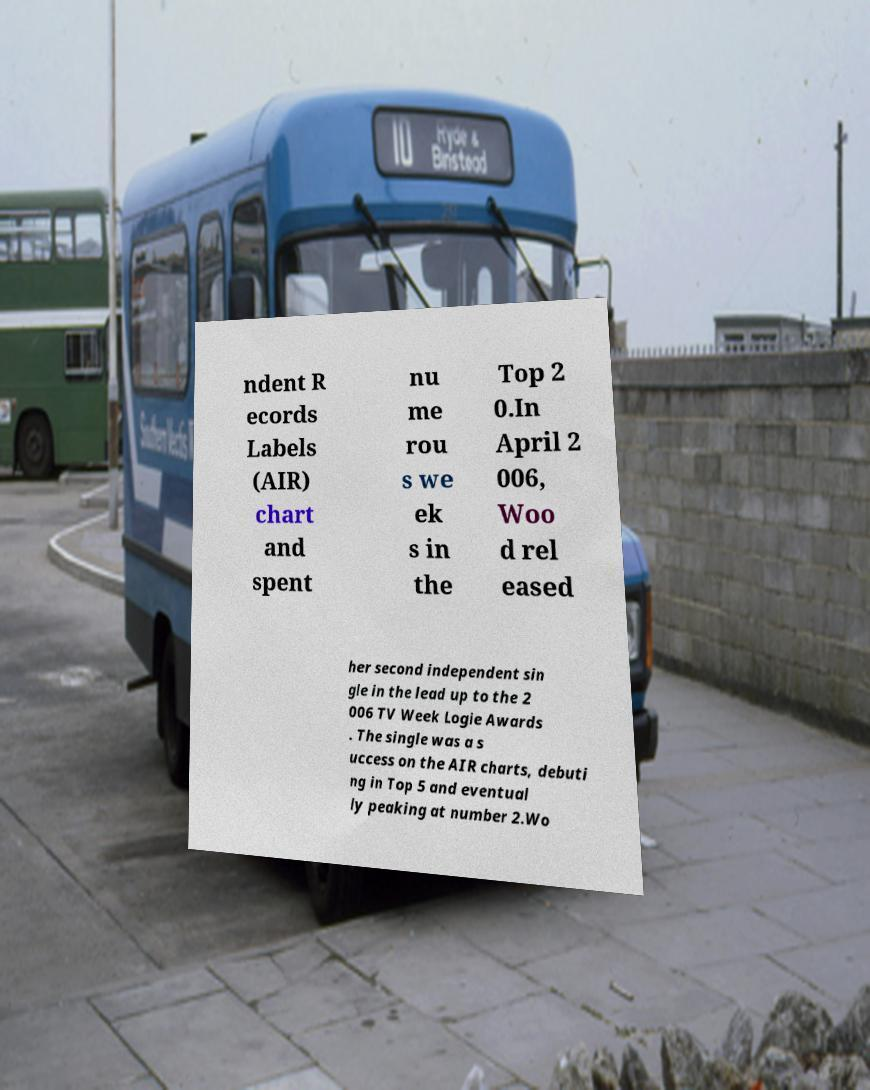Can you accurately transcribe the text from the provided image for me? ndent R ecords Labels (AIR) chart and spent nu me rou s we ek s in the Top 2 0.In April 2 006, Woo d rel eased her second independent sin gle in the lead up to the 2 006 TV Week Logie Awards . The single was a s uccess on the AIR charts, debuti ng in Top 5 and eventual ly peaking at number 2.Wo 